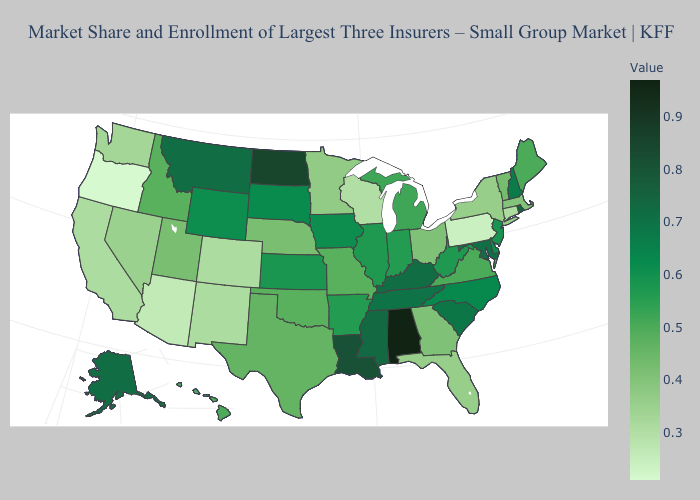Does New Mexico have a higher value than Oregon?
Quick response, please. Yes. Among the states that border Connecticut , does New York have the highest value?
Be succinct. No. Which states have the lowest value in the South?
Answer briefly. Florida. Which states have the lowest value in the Northeast?
Short answer required. Pennsylvania. Does Illinois have the lowest value in the MidWest?
Answer briefly. No. Which states hav the highest value in the South?
Answer briefly. Alabama. 